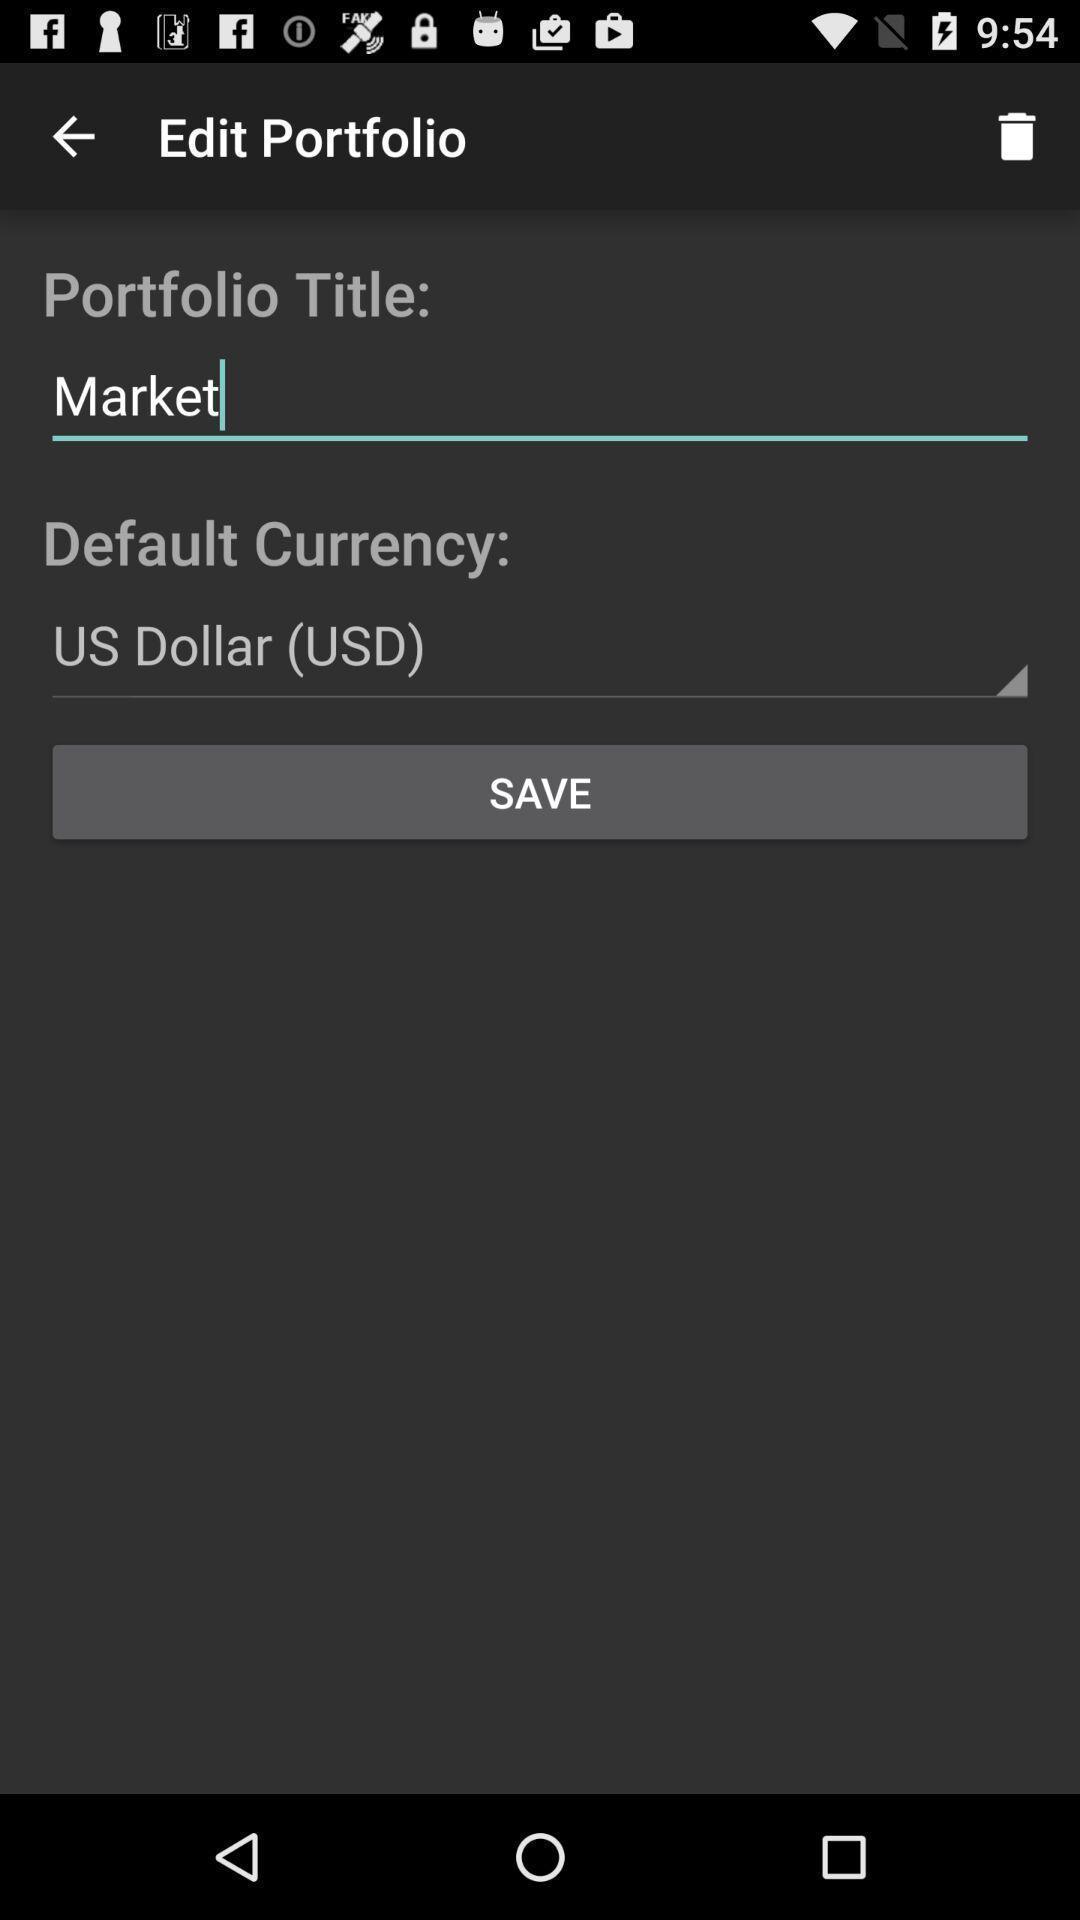Explain what's happening in this screen capture. Page for editing a portfolio. 